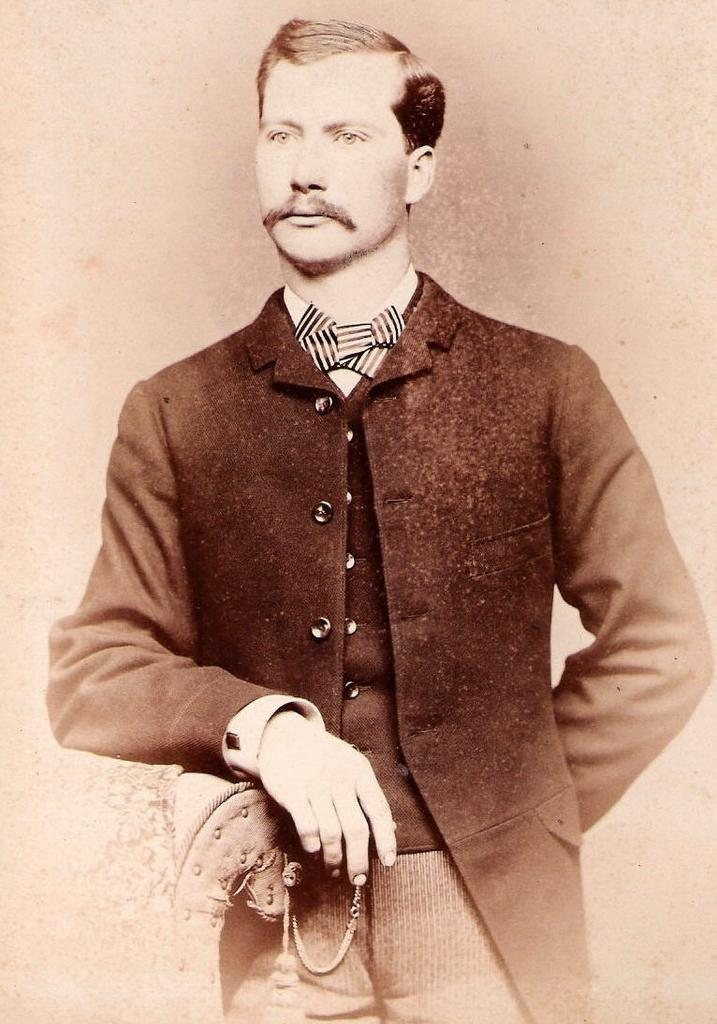What is the main subject of the image? There is a man standing in the image. What is the man doing with his hand? The man has placed his hand on a chair. What can be seen in the background of the image? There is a wall in the background of the image. What type of nut is the man cracking in the image? There is no nut present in the image; the man is simply standing with his hand on a chair. 